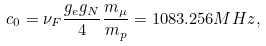Convert formula to latex. <formula><loc_0><loc_0><loc_500><loc_500>c _ { 0 } = \nu _ { F } \frac { g _ { e } g _ { N } } { 4 } \frac { m _ { \mu } } { m _ { p } } = 1 0 8 3 . 2 5 6 M H z ,</formula> 